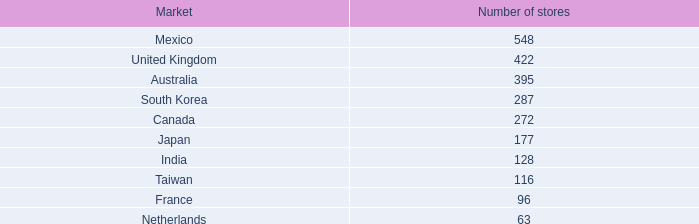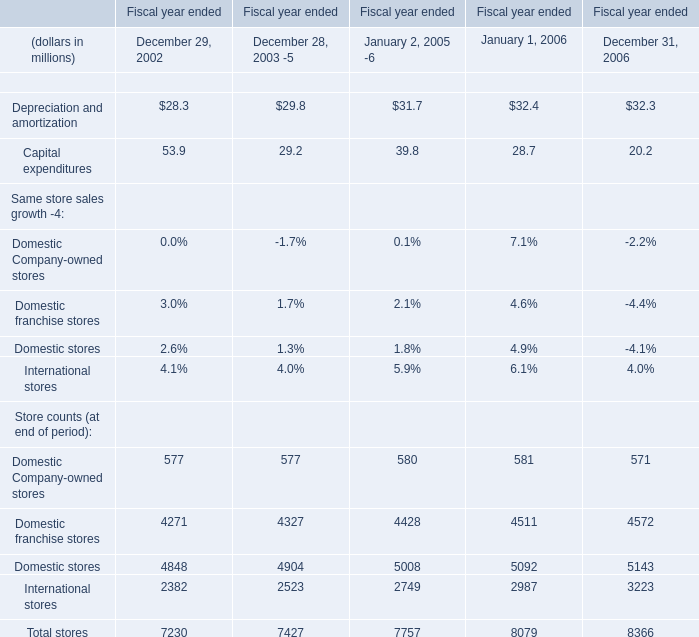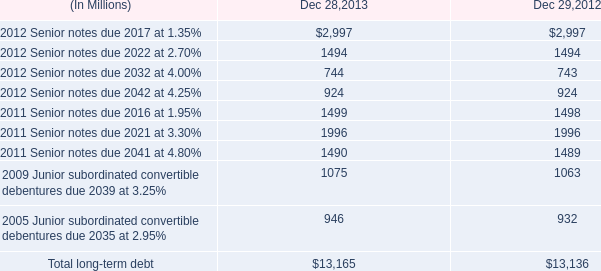what is the net cash flow from short-term debt in 2013? 
Computations: ((257 + 24) - (264 + 48))
Answer: -31.0. 